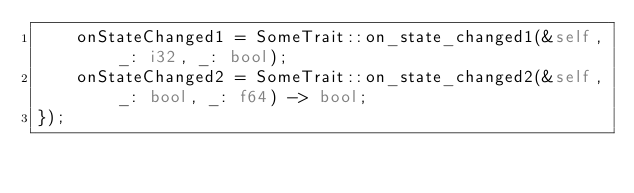<code> <loc_0><loc_0><loc_500><loc_500><_Rust_>    onStateChanged1 = SomeTrait::on_state_changed1(&self, _: i32, _: bool);
    onStateChanged2 = SomeTrait::on_state_changed2(&self, _: bool, _: f64) -> bool;
});
</code> 